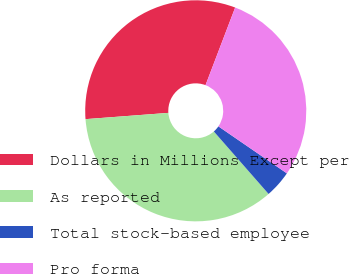Convert chart to OTSL. <chart><loc_0><loc_0><loc_500><loc_500><pie_chart><fcel>Dollars in Millions Except per<fcel>As reported<fcel>Total stock-based employee<fcel>Pro forma<nl><fcel>32.01%<fcel>35.25%<fcel>3.98%<fcel>28.77%<nl></chart> 